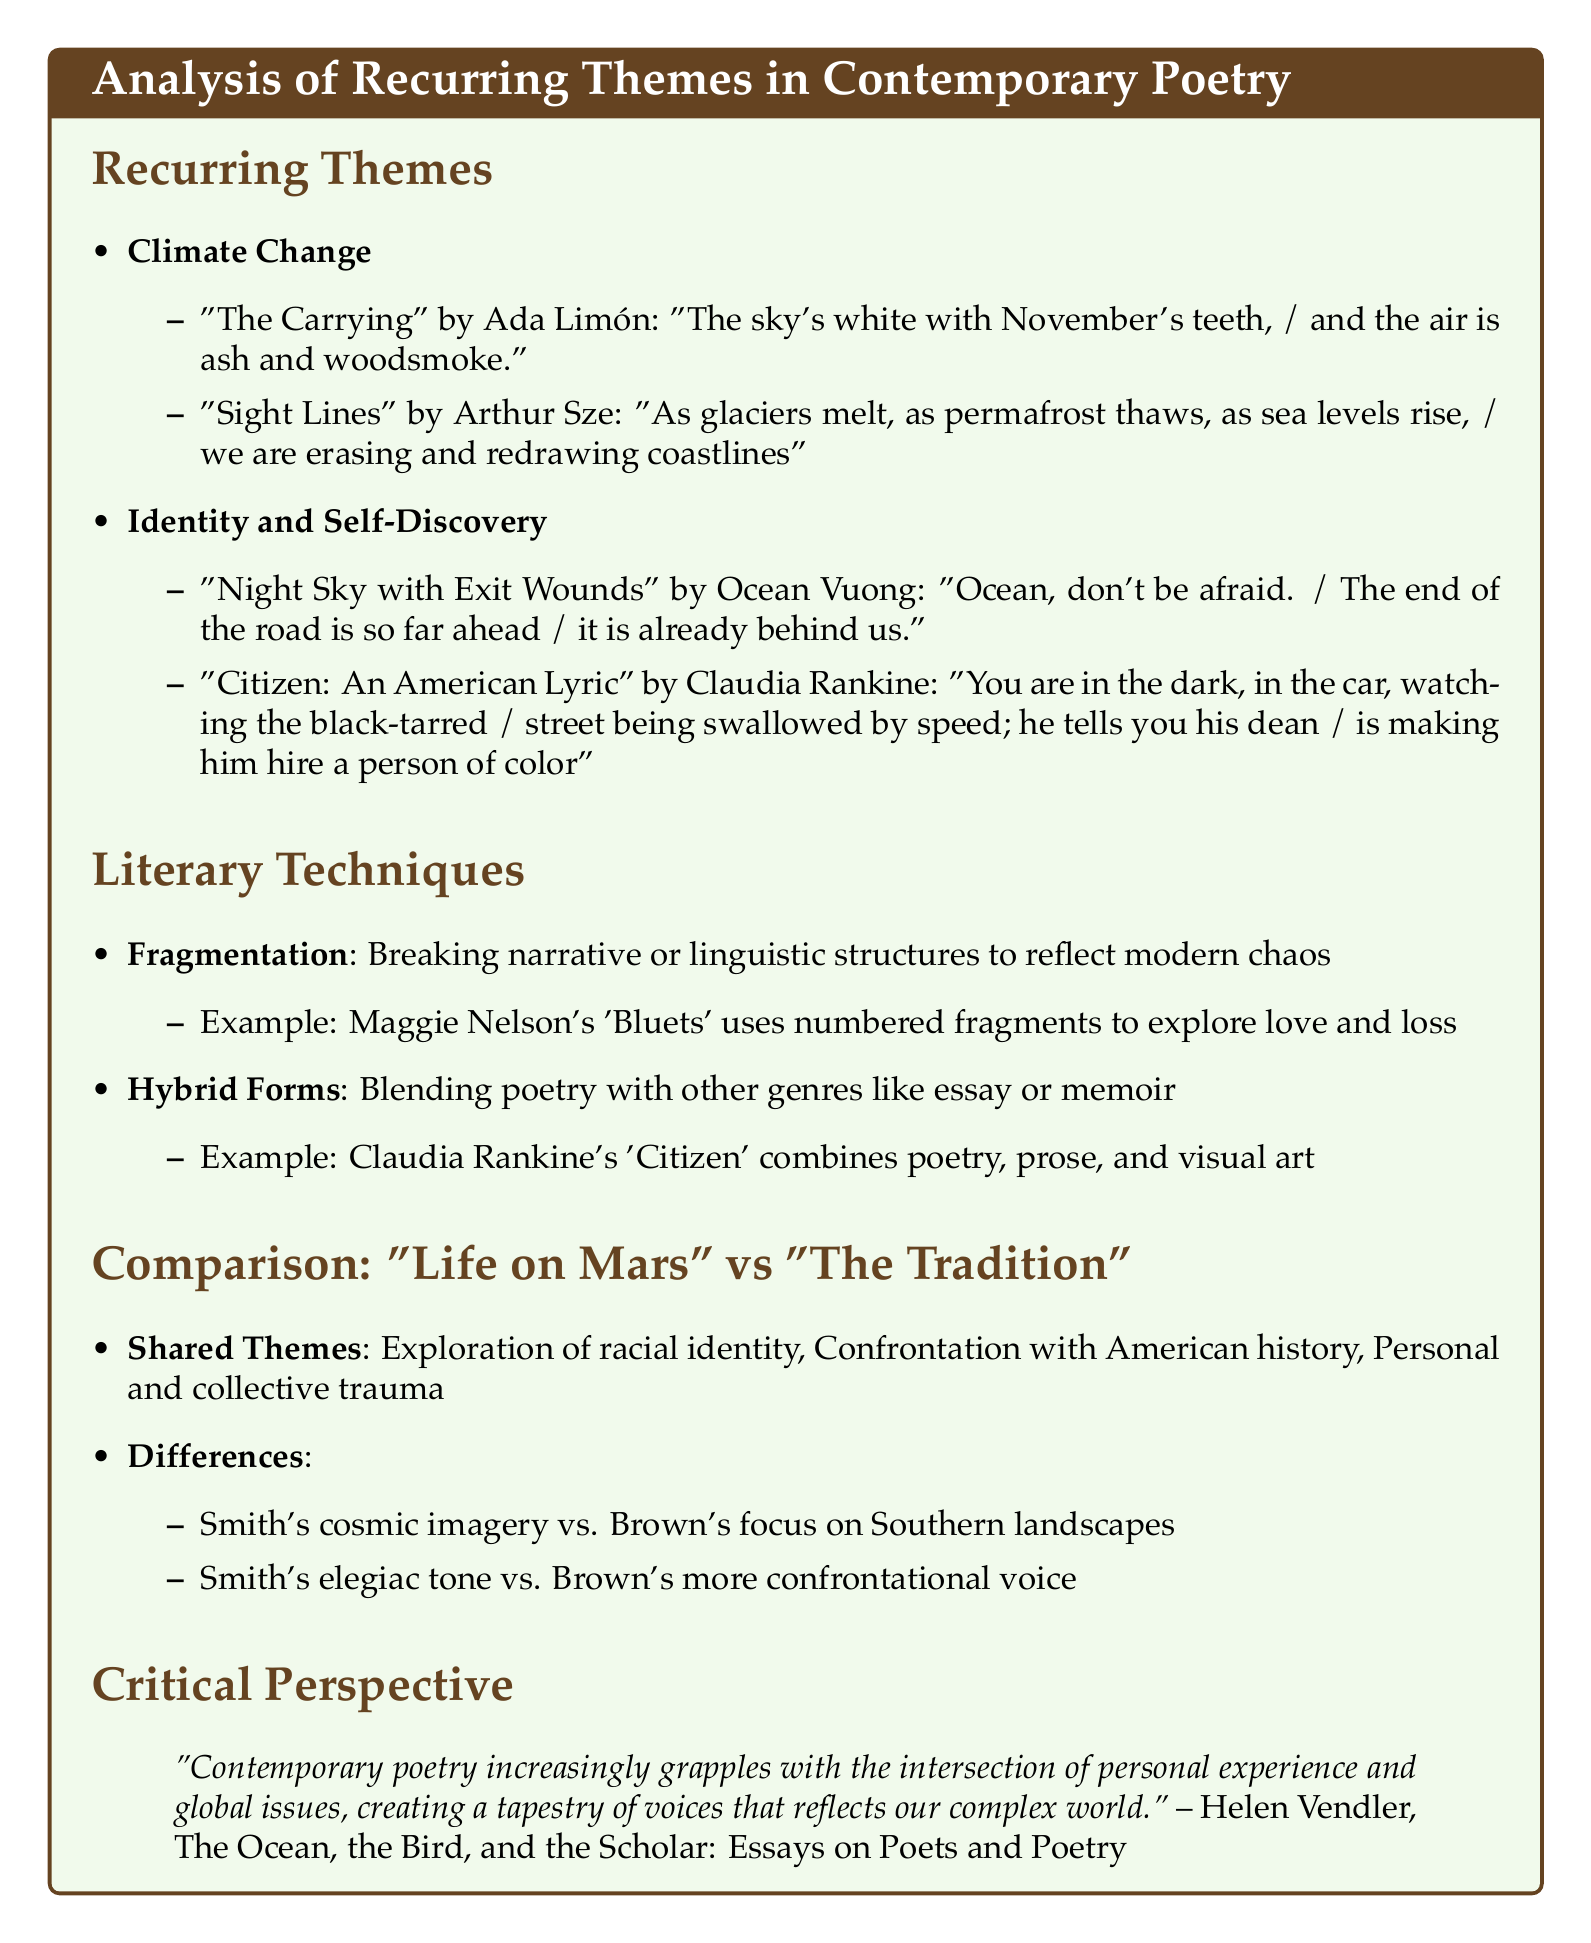what is the first theme listed in the document? The first theme is identified in the "Recurring Themes" section, which introduces "Climate Change."
Answer: Climate Change who wrote "The Carrying"? The author of "The Carrying" is mentioned along with the poem under the "Climate Change" theme.
Answer: Ada Limón which poetic technique involves blending poetry with other genres? This technique is described in the "Literary Techniques" section under "Hybrid Forms."
Answer: Hybrid Forms name one poem from "Citizen: An American Lyric." The document provides a specific poem title from the collection "Citizen: An American Lyric."
Answer: You are in the dark, in the car.. what is a shared theme in "Life on Mars" and "The Tradition"? The document lists multiple shared themes, specifically mentioning one in the "Comparison" section.
Answer: Exploration of racial identity how does Smith's tone differ from Brown's? The document outlines tonal differences between the two authors in the "Differences" section of the "Comparison."
Answer: Smith's elegiac tone who is the critic quoted in the "Critical Perspective"? The "Critical Perspective" section references a specific critic.
Answer: Helen Vendler what literary technique does Maggie Nelson use in 'Bluets'? The document describes the specific narrative style used by Maggie Nelson in her work.
Answer: Fragmentation how many examples are provided under the theme of Identity and Self-Discovery? The document explicitly lists the number of poems that exemplify the theme.
Answer: Two 